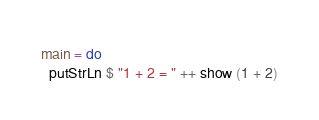<code> <loc_0><loc_0><loc_500><loc_500><_Haskell_>main = do
  putStrLn $ "1 + 2 = " ++ show (1 + 2)
</code> 